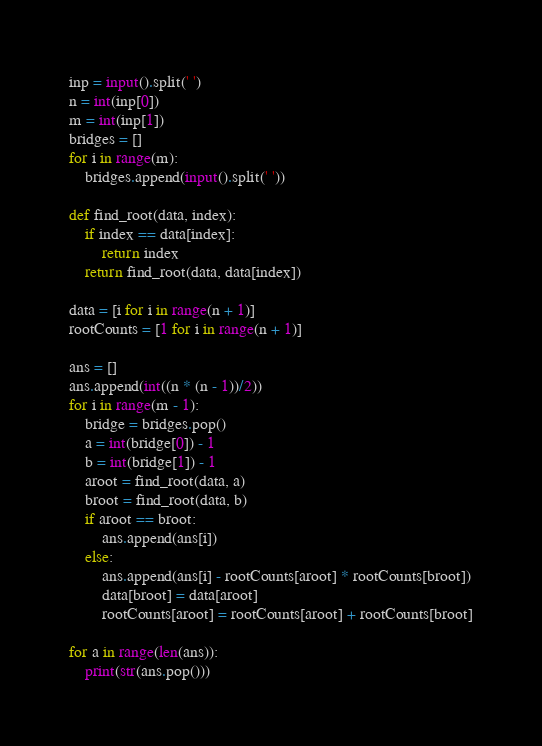Convert code to text. <code><loc_0><loc_0><loc_500><loc_500><_Python_>inp = input().split(' ')
n = int(inp[0])
m = int(inp[1])
bridges = []
for i in range(m):
    bridges.append(input().split(' '))

def find_root(data, index):
    if index == data[index]:
        return index
    return find_root(data, data[index])

data = [i for i in range(n + 1)]
rootCounts = [1 for i in range(n + 1)]

ans = []
ans.append(int((n * (n - 1))/2))
for i in range(m - 1):
    bridge = bridges.pop()
    a = int(bridge[0]) - 1
    b = int(bridge[1]) - 1
    aroot = find_root(data, a)
    broot = find_root(data, b)
    if aroot == broot:
        ans.append(ans[i])
    else:
        ans.append(ans[i] - rootCounts[aroot] * rootCounts[broot])
        data[broot] = data[aroot]
        rootCounts[aroot] = rootCounts[aroot] + rootCounts[broot]

for a in range(len(ans)):
    print(str(ans.pop()))
</code> 